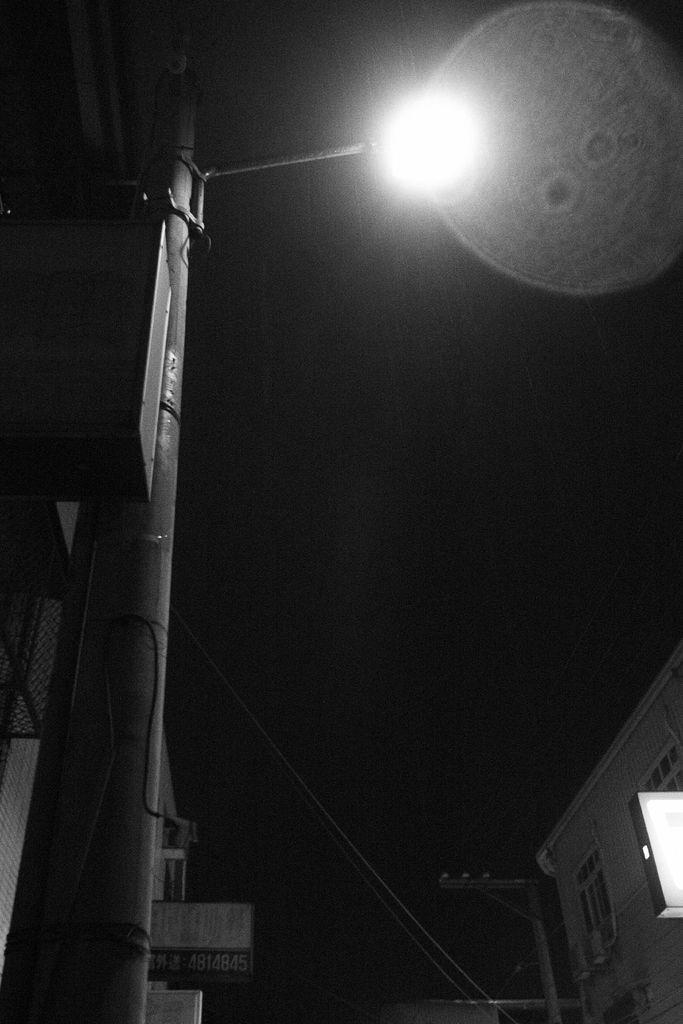Can you describe this image briefly? In this image I can see the light pole, background I can see few buildings and the sky is in black color. 